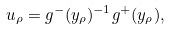Convert formula to latex. <formula><loc_0><loc_0><loc_500><loc_500>u _ { \rho } = g ^ { - } ( y _ { \rho } ) ^ { - 1 } g ^ { + } ( y _ { \rho } ) ,</formula> 